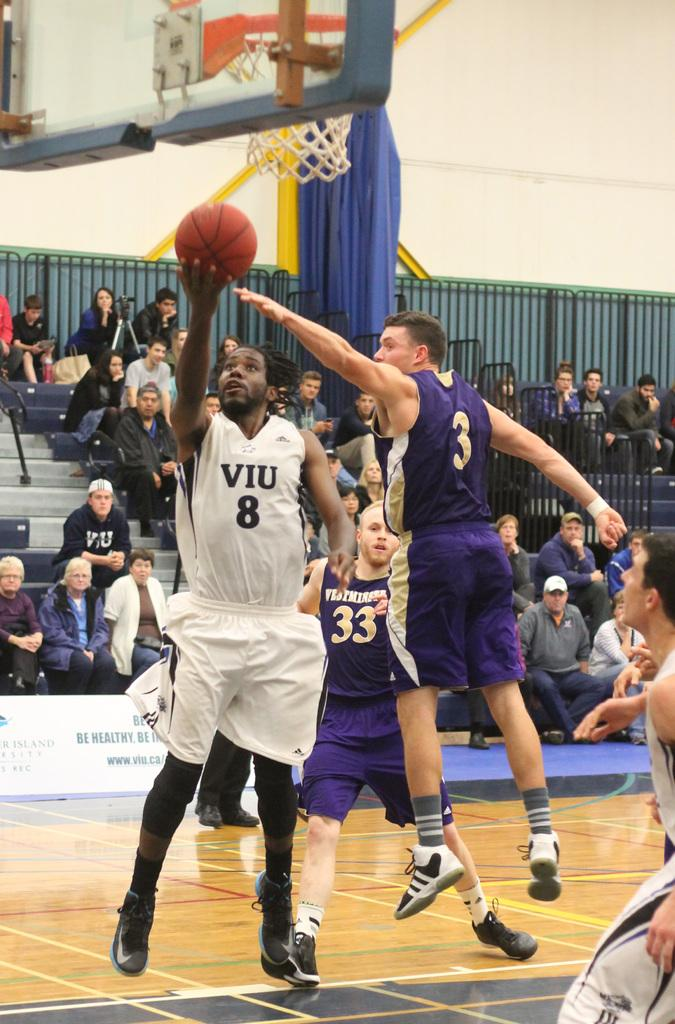<image>
Write a terse but informative summary of the picture. The player in blue is wearing the number 3 